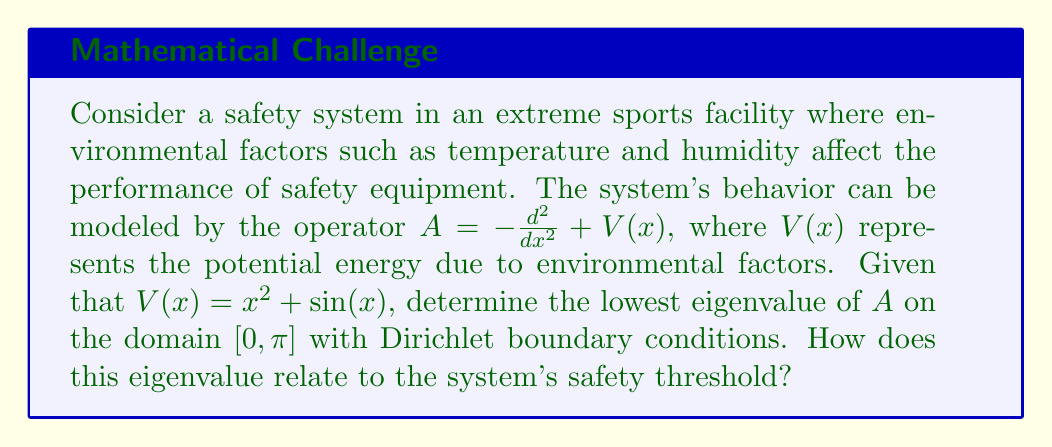Show me your answer to this math problem. To solve this problem, we'll use spectral theory and variational methods:

1) The operator $A = -\frac{d^2}{dx^2} + V(x)$ is a Sturm-Liouville operator with $V(x) = x^2 + \sin(x)$ as the potential function.

2) The lowest eigenvalue $\lambda_1$ of $A$ can be found using the Rayleigh-Ritz variational principle:

   $$\lambda_1 = \inf_{f \in H^1_0([0,\pi])} \frac{\int_0^\pi (|f'(x)|^2 + V(x)|f(x)|^2) dx}{\int_0^\pi |f(x)|^2 dx}$$

3) We can approximate $\lambda_1$ by choosing a trial function that satisfies the boundary conditions. A good choice is $f(x) = \sin(x)$, which vanishes at $x=0$ and $x=\pi$.

4) Substituting this into the Rayleigh quotient:

   $$\lambda_1 \approx \frac{\int_0^\pi (|\cos(x)|^2 + (x^2 + \sin(x))|\sin(x)|^2) dx}{\int_0^\pi |\sin(x)|^2 dx}$$

5) Evaluating the integrals:
   
   Numerator: $\int_0^\pi \cos^2(x) dx = \frac{\pi}{2}$
              $\int_0^\pi x^2 \sin^2(x) dx = \frac{\pi^3 - 2\pi}{4}$
              $\int_0^\pi \sin^3(x) dx = \frac{4}{3}$
   
   Denominator: $\int_0^\pi \sin^2(x) dx = \frac{\pi}{2}$

6) Substituting these values:

   $$\lambda_1 \approx \frac{\frac{\pi}{2} + \frac{\pi^3 - 2\pi}{4} + \frac{4}{3}}{\frac{\pi}{2}} = 1 + \frac{\pi^2}{4} + \frac{8}{3\pi} \approx 3.7$$

This approximation gives us an upper bound for the true lowest eigenvalue.

The lowest eigenvalue relates to the system's safety threshold as it represents the minimum energy state of the system. A lower value indicates a more stable system, while a higher value suggests the system is more susceptible to environmental factors and potentially less safe.
Answer: The approximate lowest eigenvalue of the operator $A = -\frac{d^2}{dx^2} + V(x)$ with $V(x) = x^2 + \sin(x)$ on $[0, \pi]$ is $\lambda_1 \approx 3.7$. This value represents an upper bound for the true lowest eigenvalue and indicates the system's sensitivity to environmental factors, with higher values suggesting a potentially less safe system. 